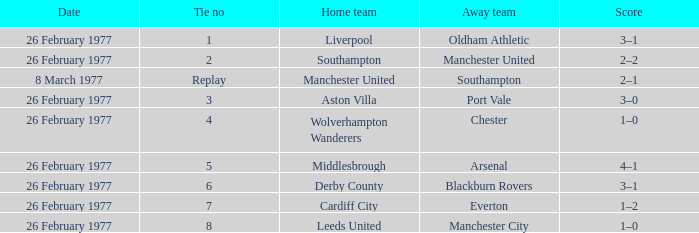Would you be able to parse every entry in this table? {'header': ['Date', 'Tie no', 'Home team', 'Away team', 'Score'], 'rows': [['26 February 1977', '1', 'Liverpool', 'Oldham Athletic', '3–1'], ['26 February 1977', '2', 'Southampton', 'Manchester United', '2–2'], ['8 March 1977', 'Replay', 'Manchester United', 'Southampton', '2–1'], ['26 February 1977', '3', 'Aston Villa', 'Port Vale', '3–0'], ['26 February 1977', '4', 'Wolverhampton Wanderers', 'Chester', '1–0'], ['26 February 1977', '5', 'Middlesbrough', 'Arsenal', '4–1'], ['26 February 1977', '6', 'Derby County', 'Blackburn Rovers', '3–1'], ['26 February 1977', '7', 'Cardiff City', 'Everton', '1–2'], ['26 February 1977', '8', 'Leeds United', 'Manchester City', '1–0']]} What date was Chester the away team? 26 February 1977. 